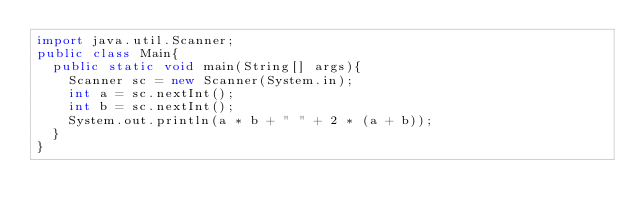Convert code to text. <code><loc_0><loc_0><loc_500><loc_500><_Java_>import java.util.Scanner;
public class Main{
  public static void main(String[] args){
    Scanner sc = new Scanner(System.in);
    int a = sc.nextInt();
    int b = sc.nextInt();
    System.out.println(a * b + " " + 2 * (a + b));
  }
}

</code> 